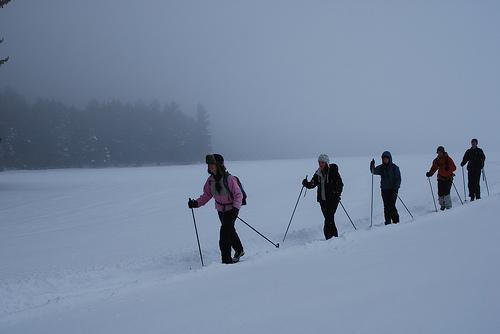How many people are there?
Give a very brief answer. 5. 